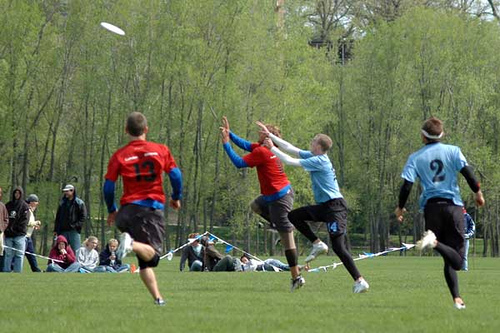What does the players' body language tell us about the moment captured? The intense focus and outstretched limbs of the players suggest a critical moment in the game – likely a pass or an interception attempt. Their body language conveys urgency, athleticism, and a high level of engagement in the heat of the action. Who appears to be in control of the game at this moment? It's not clear who has the upper hand from this snapshot alone, but the player in blue, with his eyes on the frisbee and arms outstretched, seems to be making a determined effort to catch or defend the disc, which could indicate his team is actively in play. 